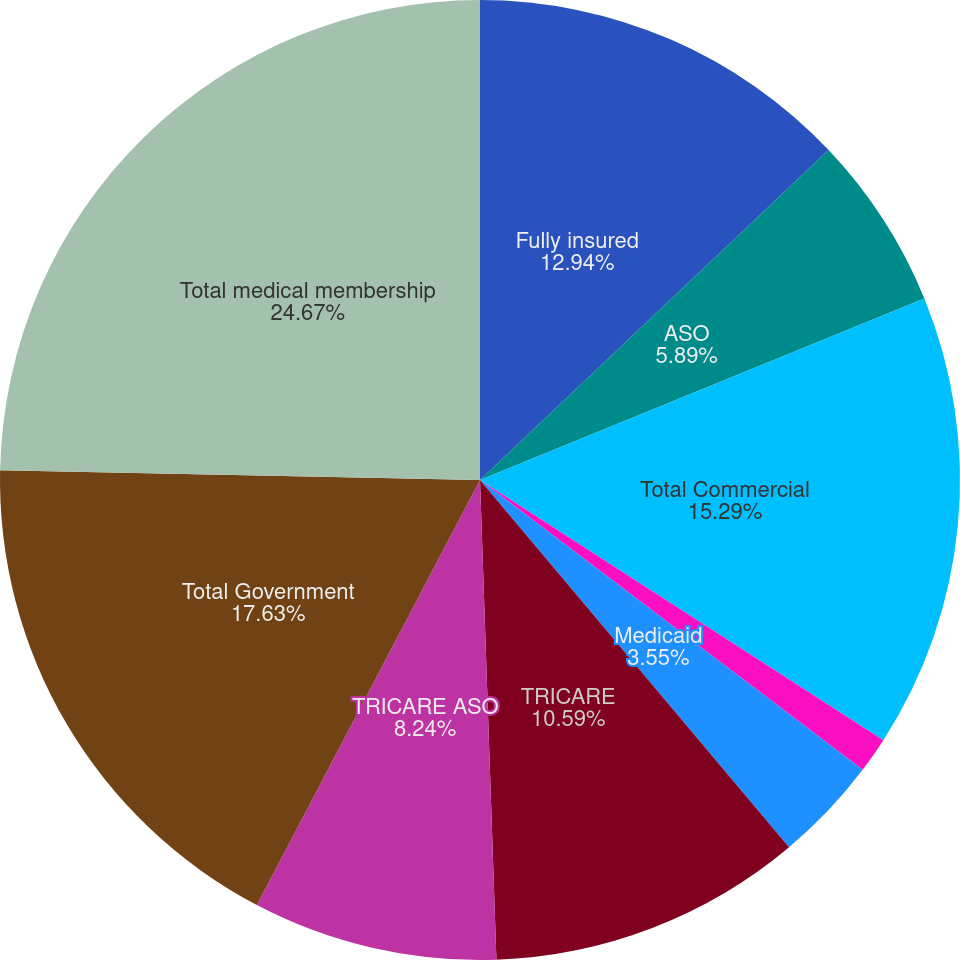<chart> <loc_0><loc_0><loc_500><loc_500><pie_chart><fcel>Fully insured<fcel>ASO<fcel>Total Commercial<fcel>Medicare+Choice<fcel>Medicaid<fcel>TRICARE<fcel>TRICARE ASO<fcel>Total Government<fcel>Total medical membership<nl><fcel>12.94%<fcel>5.89%<fcel>15.29%<fcel>1.2%<fcel>3.55%<fcel>10.59%<fcel>8.24%<fcel>17.63%<fcel>24.68%<nl></chart> 